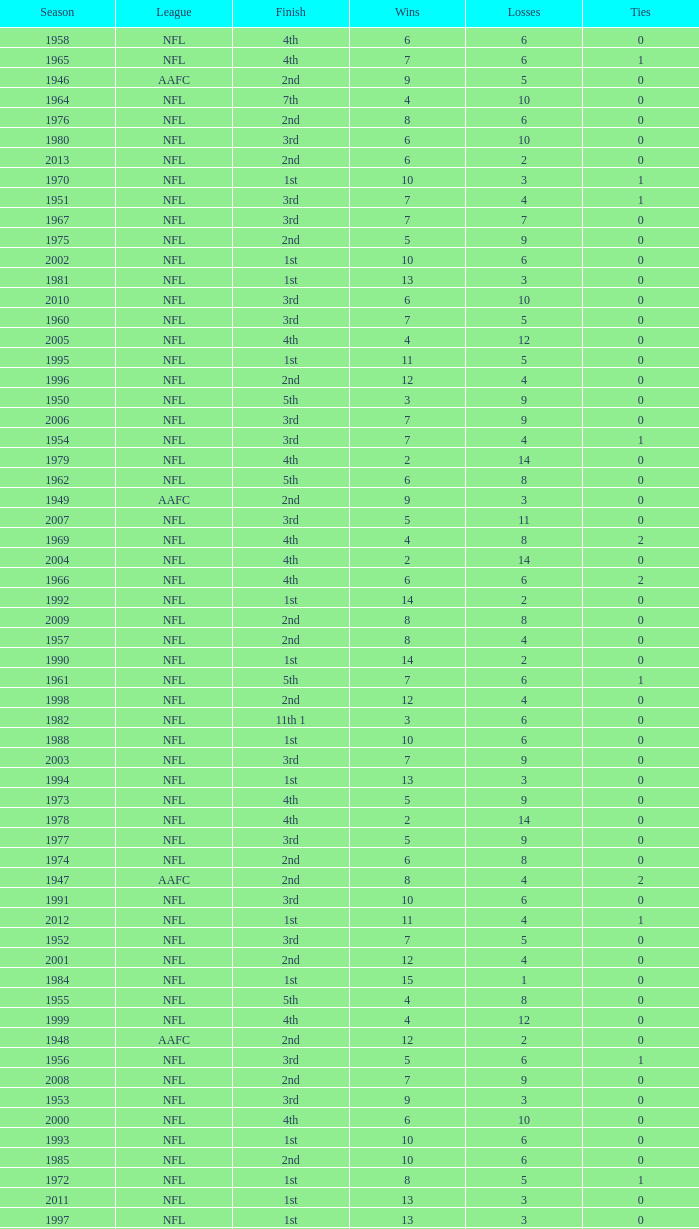What is the losses in the NFL in the 2011 season with less than 13 wins? None. 